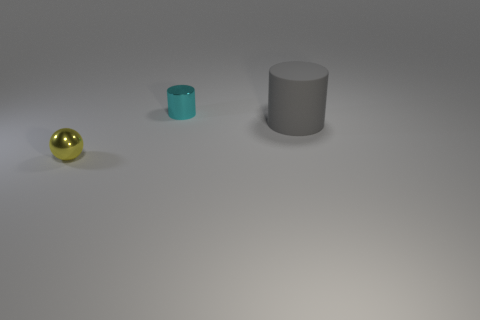Subtract all cyan cylinders. How many cylinders are left? 1 Add 2 small yellow objects. How many objects exist? 5 Subtract all cylinders. How many objects are left? 1 Subtract 0 blue cylinders. How many objects are left? 3 Subtract 2 cylinders. How many cylinders are left? 0 Subtract all brown spheres. Subtract all gray cylinders. How many spheres are left? 1 Subtract all cyan balls. How many cyan cylinders are left? 1 Subtract all big purple cylinders. Subtract all gray cylinders. How many objects are left? 2 Add 1 balls. How many balls are left? 2 Add 3 tiny cylinders. How many tiny cylinders exist? 4 